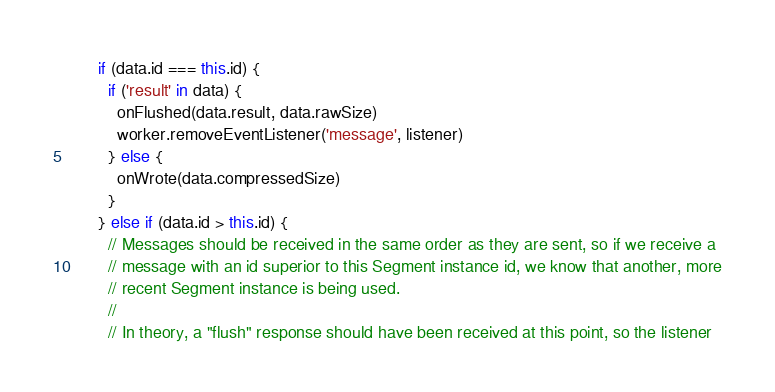Convert code to text. <code><loc_0><loc_0><loc_500><loc_500><_TypeScript_>
      if (data.id === this.id) {
        if ('result' in data) {
          onFlushed(data.result, data.rawSize)
          worker.removeEventListener('message', listener)
        } else {
          onWrote(data.compressedSize)
        }
      } else if (data.id > this.id) {
        // Messages should be received in the same order as they are sent, so if we receive a
        // message with an id superior to this Segment instance id, we know that another, more
        // recent Segment instance is being used.
        //
        // In theory, a "flush" response should have been received at this point, so the listener</code> 